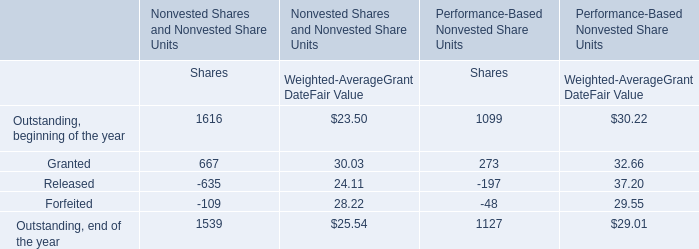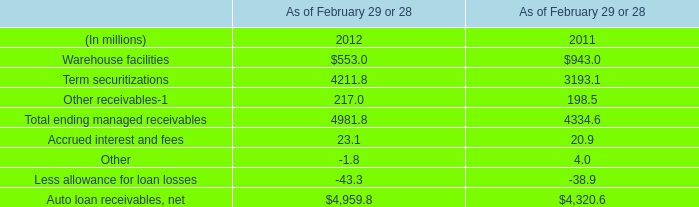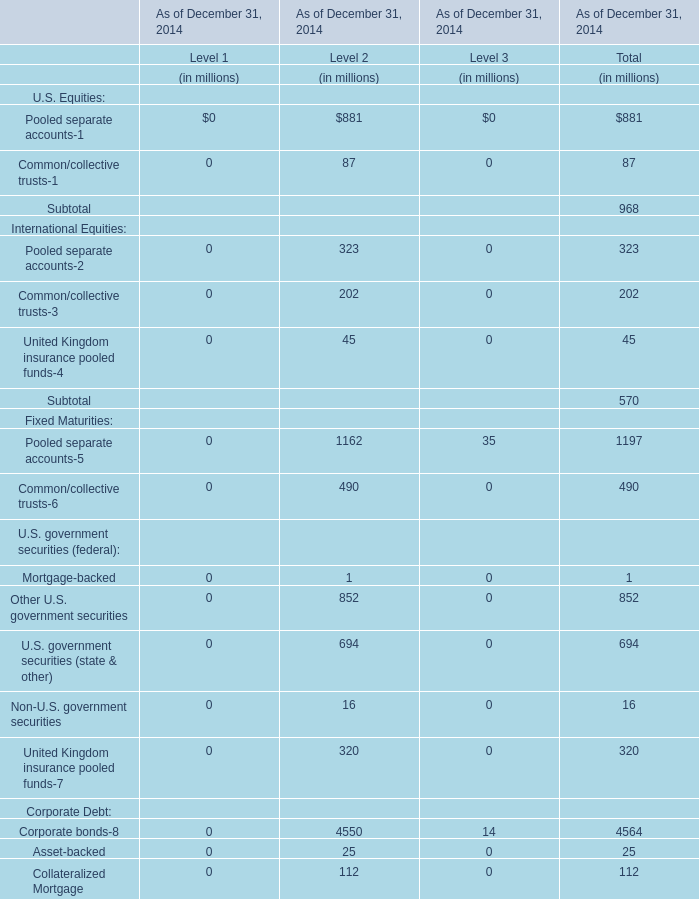What's the 18 % of total elements for Level 3 in 2014? (in millions) 
Computations: (2522 * 0.18)
Answer: 453.96. 